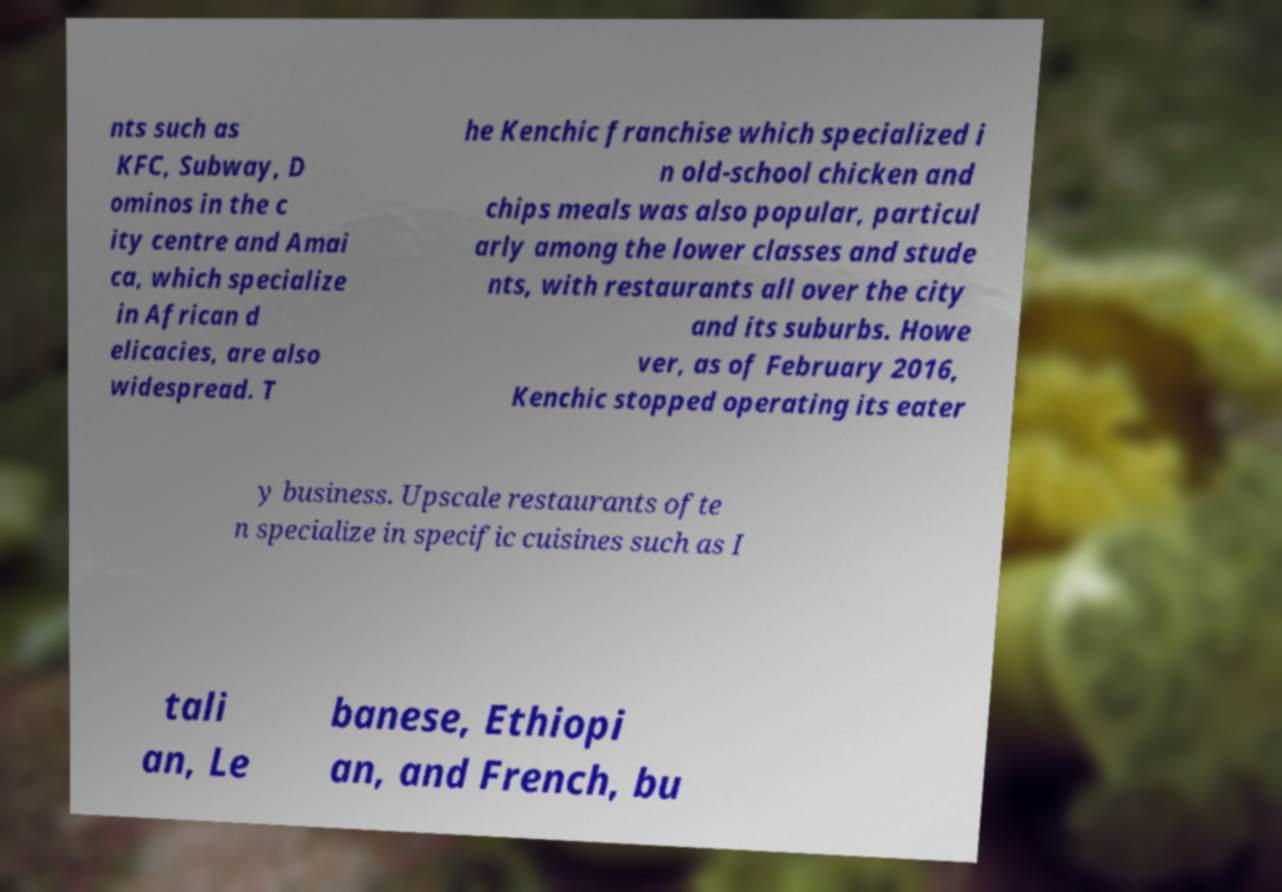I need the written content from this picture converted into text. Can you do that? nts such as KFC, Subway, D ominos in the c ity centre and Amai ca, which specialize in African d elicacies, are also widespread. T he Kenchic franchise which specialized i n old-school chicken and chips meals was also popular, particul arly among the lower classes and stude nts, with restaurants all over the city and its suburbs. Howe ver, as of February 2016, Kenchic stopped operating its eater y business. Upscale restaurants ofte n specialize in specific cuisines such as I tali an, Le banese, Ethiopi an, and French, bu 